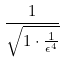Convert formula to latex. <formula><loc_0><loc_0><loc_500><loc_500>\frac { 1 } { \sqrt { 1 \cdot \frac { 1 } { \epsilon ^ { 4 } } } }</formula> 